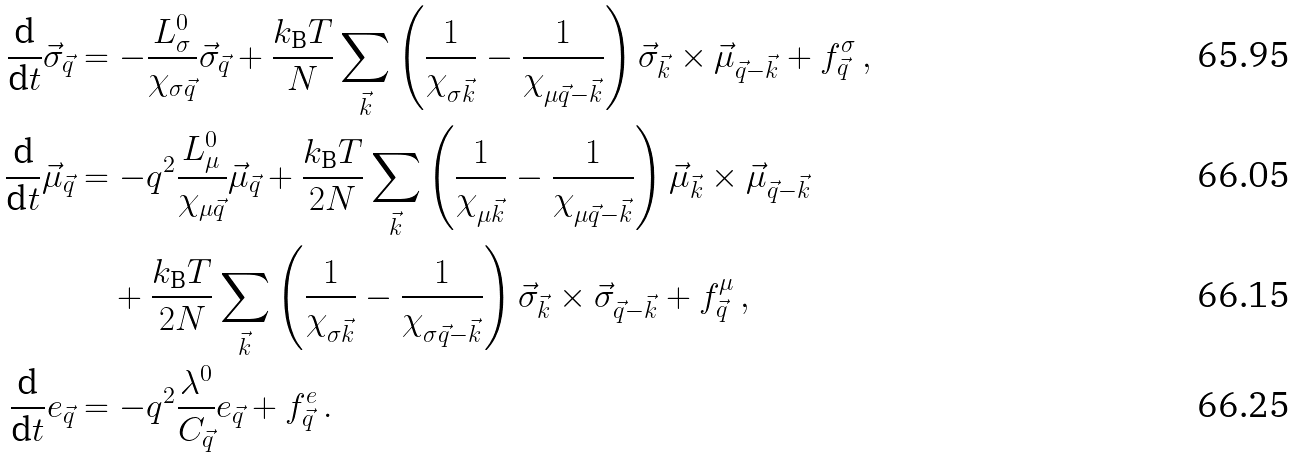<formula> <loc_0><loc_0><loc_500><loc_500>\frac { \text  d}{\text  d t}\vec{\sigma}_{\vec{q} } & = - \frac { L _ { \sigma } ^ { 0 } } { \chi _ { \sigma \vec { q } } } \vec { \sigma } _ { \vec { q } } + \frac { k _ { \text  B}T}{N}\sum_{\vec{k}} \left( \frac{1}{\chi_{\sigma\vec{k} } } - \frac { 1 } { \chi _ { \mu \vec { q } - \vec { k } } } \right ) \vec { \sigma } _ { \vec { k } } \times \vec { \mu } _ { \vec { q } - \vec { k } } + f _ { \vec { q } } ^ { \sigma } \, , \\ \frac { \text  d}{\text  d t}\vec{\mu}_{\vec{q} } & = - q ^ { 2 } \frac { L _ { \mu } ^ { 0 } } { \chi _ { \mu \vec { q } } } \vec { \mu } _ { \vec { q } } + \frac { k _ { \text  B}T}{2N}\sum_{\vec{k}} \left( \frac{1}{\chi_{\mu\vec{k} } } - \frac { 1 } { \chi _ { \mu \vec { q } - \vec { k } } } \right ) \vec { \mu } _ { \vec { k } } \times \vec { \mu } _ { \vec { q } - \vec { k } } \\ & \quad + \frac { k _ { \text  B}T}{2N}\sum_{\vec{k}} \left( \frac{1}{\chi_{\sigma\vec{k} } } - \frac { 1 } { \chi _ { \sigma \vec { q } - \vec { k } } } \right ) \vec { \sigma } _ { \vec { k } } \times \vec { \sigma } _ { \vec { q } - \vec { k } } + f _ { \vec { q } } ^ { \mu } \, , \\ \frac { \text  d}{\text  d t}e_{\vec{q} } & = - q ^ { 2 } \frac { \lambda ^ { 0 } } { C _ { \vec { q } } } e _ { \vec { q } } + f _ { \vec { q } } ^ { e } \, .</formula> 